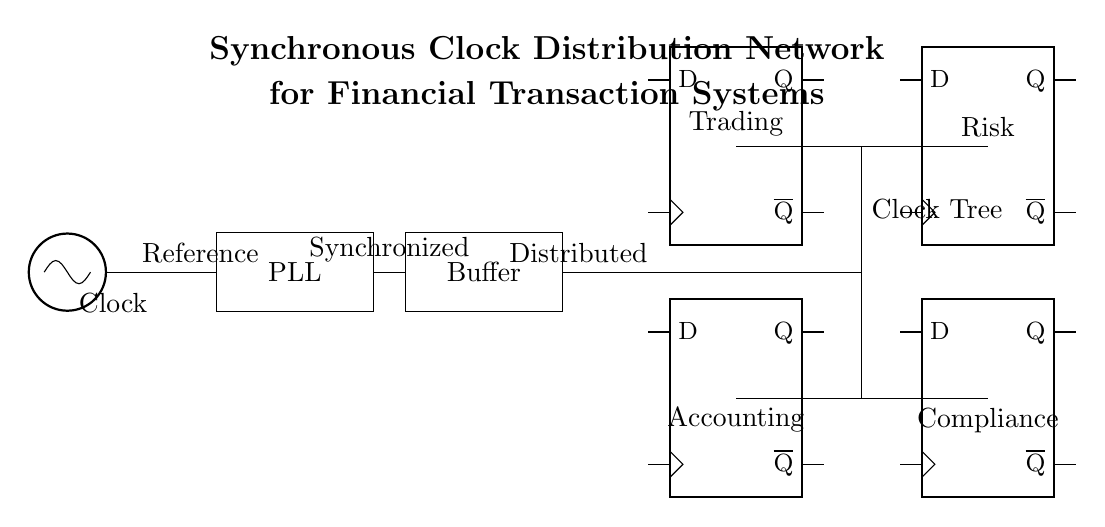What is the primary component that generates the clock signal? The primary component generating the clock signal is labeled as "Clock" in the diagram. It is depicted as an oscillator, which is typically used to create periodic signals required for synchronization.
Answer: Clock What does the PLL stand for in this circuit? The PLL stands for Phase-Locked Loop, which is represented as a rectangle in the circuit. It is used for synchronizing the frequency of the clock signal to a reference signal, ensuring that the timing is precise across the network.
Answer: Phase-Locked Loop Which components are used for synchronous timing distribution? The components used for synchronous timing distribution in this circuit include the oscillator, PLL, buffer, and the clock tree. The buffer acts to strengthen the signal before it is distributed, ensuring minimal signal degradation.
Answer: Oscillator, PLL, Buffer, Clock Tree How many flip-flops are shown in the circuit diagram? There are four flip-flops shown in the diagram, positioned in two rows. These flip-flops are essential for storing and shifting the timing signals throughout the system, which is critical for timing synchronization in financial transaction systems.
Answer: Four What is the purpose of the clock tree in this circuit? The purpose of the clock tree is to distribute the synchronized clock signal to various components in the system, specifically the trading and accounting sections. This ensures that all parts of the system operate with the same timing reference, which is vital for coordinated operations.
Answer: Distribute synchronized clock signals Which operational segment is labeled as “Risk” in the diagram? The operational segment labeled as "Risk" is connected to the upper flip-flop in the diagram, indicating that it receives the distributed clock signal for timing coordination within the risk management function of the financial transaction system.
Answer: Risk 